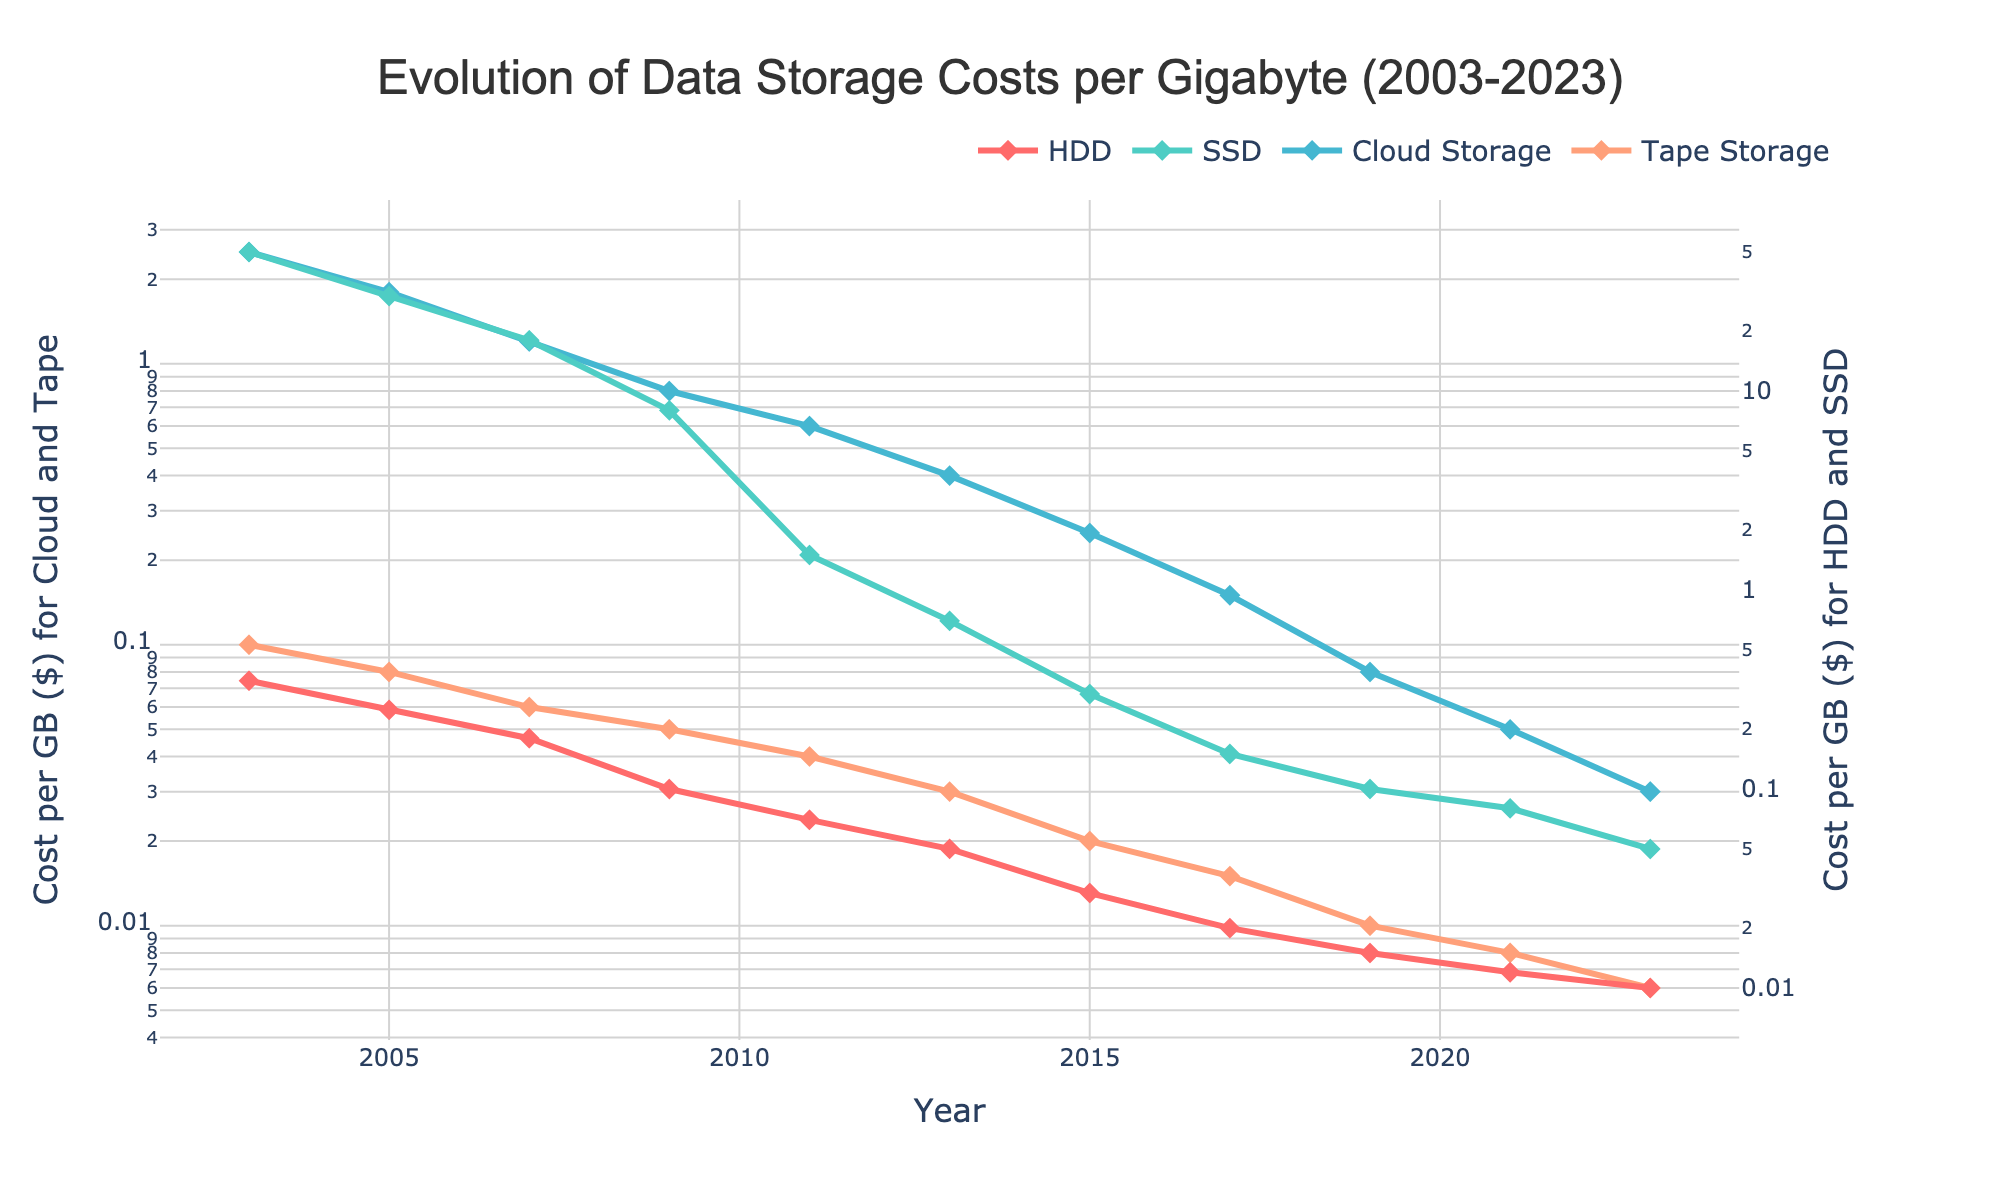What is the general trend of HDD costs per GB from 2003 to 2023? The trend of HDD costs per GB shows a consistent decrease over the years from 0.35 in 2003 to 0.01 in 2023.
Answer: A consistent decrease Which storage type had the highest cost per GB in 2003? Referring to the year 2003, SSD had the highest cost per GB at 50.00.
Answer: SSD In which year did SSD costs per GB first drop below 1.00? The SSD costs per GB first dropped below 1.00 in the year 2013 when it reached 0.70.
Answer: 2013 By how much did the cost per GB for HDD decrease from 2003 to 2023? The cost per GB for HDD decreased from 0.35 in 2003 to 0.01 in 2023. The reduction is 0.35 - 0.01 = 0.34.
Answer: 0.34 Which storage type shows the slowest rate of cost decline over the time period covered in the data? Comparing the slope of the decrease in costs over the years, Cloud Storage shows the slowest rate of decline from 2.50 in 2003 to 0.03 in 2023.
Answer: Cloud Storage What is the difference in cost per GB between Cloud Storage and Tape Storage in 2023? In 2023, the cost per GB for Cloud Storage is 0.03, while for Tape Storage, it is 0.006. The difference is 0.03 - 0.006 = 0.024.
Answer: 0.024 Which storage type had the largest decrease in cost per GB from 2003 to 2023 in absolute terms? By comparing the initial and final values, SSD had the largest decrease in cost per GB from 50.00 in 2003 to 0.05 in 2023, an absolute reduction of 50.00 - 0.05 = 49.95.
Answer: SSD What is the average cost per GB for Cloud Storage from 2003 to 2023? The sum of Cloud Storage costs from 2003 to 2023 is 2.50 + 1.80 + 1.20 + 0.80 + 0.60 + 0.40 + 0.25 + 0.15 + 0.08 + 0.05 + 0.03 = 7.86. There are 11 data points, so the average is 7.86 / 11 ≈ 0.714.
Answer: 0.714 Which storage type is represented by the red line in the plot? The storage type represented by the red line is HDD as per the code that specifies color for the storage types.
Answer: HDD 